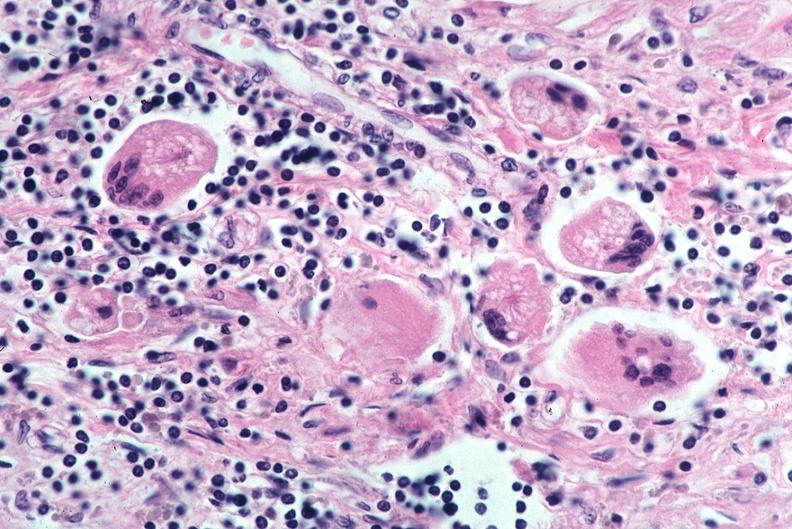how does this image show lung, sarcoidosis, multinucleated giant cells?
Answer the question using a single word or phrase. With asteroid bodies 